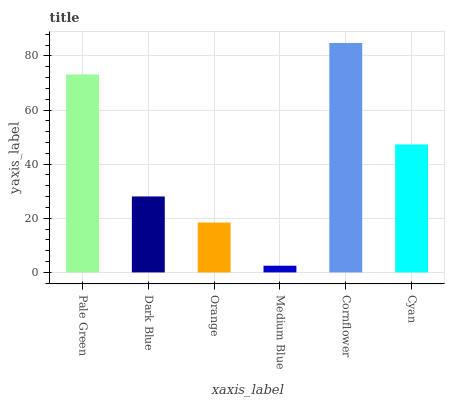Is Dark Blue the minimum?
Answer yes or no. No. Is Dark Blue the maximum?
Answer yes or no. No. Is Pale Green greater than Dark Blue?
Answer yes or no. Yes. Is Dark Blue less than Pale Green?
Answer yes or no. Yes. Is Dark Blue greater than Pale Green?
Answer yes or no. No. Is Pale Green less than Dark Blue?
Answer yes or no. No. Is Cyan the high median?
Answer yes or no. Yes. Is Dark Blue the low median?
Answer yes or no. Yes. Is Orange the high median?
Answer yes or no. No. Is Medium Blue the low median?
Answer yes or no. No. 